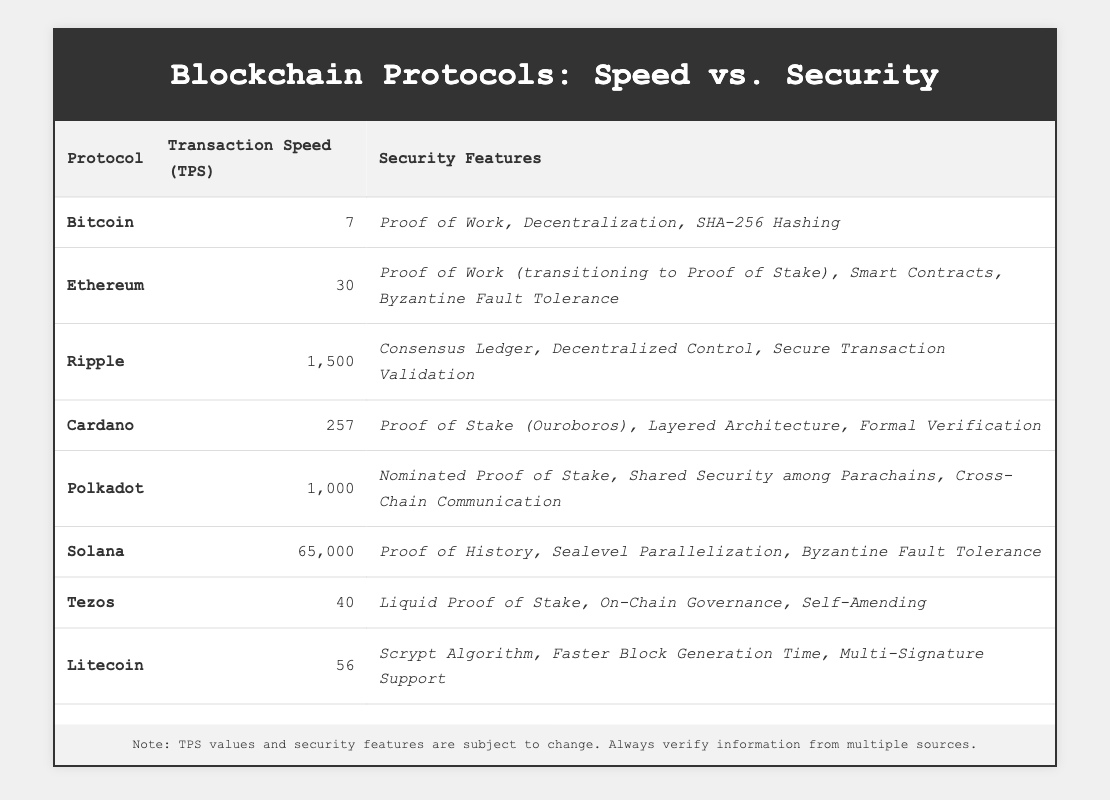What is the transaction speed of Ripple? The table shows that Ripple has a transaction speed of 1,500 TPS.
Answer: 1,500 TPS Which blockchain protocol has the highest transaction speed? According to the table, Solana has the highest transaction speed listed as 65,000 TPS.
Answer: Solana Does Bitcoin have higher transaction speed than Tezos? The transaction speed for Bitcoin is 7 TPS and for Tezos is 40 TPS. Since 7 is less than 40, Bitcoin does not have a higher transaction speed than Tezos.
Answer: No What is the average transaction speed of the protocols listed? To find the average, add the transaction speeds: 7 + 30 + 1,500 + 257 + 1,000 + 65,000 + 40 + 56 = 68,890. Then divide by 8 (the number of protocols) which gives 8,611.25.
Answer: 8,611.25 TPS Which two protocols together have a transaction speed greater than 1,000 TPS? From the table, Polkadot has 1,000 TPS and Ripple has 1,500 TPS. Adding these gives a total of 2,500 TPS, which is greater than 1,000 TPS.
Answer: Polkadot and Ripple Is Cardano more secure than Bitcoin based on the security features listed? Cardano is using Proof of Stake which is considered more efficient than Bitcoin’s Proof of Work, along with features such as Formal Verification. Therefore, it could be argued that Cardano has security advantages over Bitcoin.
Answer: Yes What security features does Solana provide? The table lists Solana’s security features as Proof of History, Sealevel Parallelization, and Byzantine Fault Tolerance.
Answer: Proof of History, Sealevel Parallelization, Byzantine Fault Tolerance How much faster is Ripple than Litecoin in terms of transaction speed? Ripple has a speed of 1,500 TPS and Litecoin has 56 TPS. The difference is 1,500 - 56 = 1,444 TPS, indicating Ripple is 1,444 TPS faster than Litecoin.
Answer: 1,444 TPS Which protocol has a lower transaction speed than Ethereum but higher than Tezos? Tezos has 40 TPS and Ethereum has 30 TPS, but no protocol fits this criterion since none appears in between their speeds.
Answer: None 